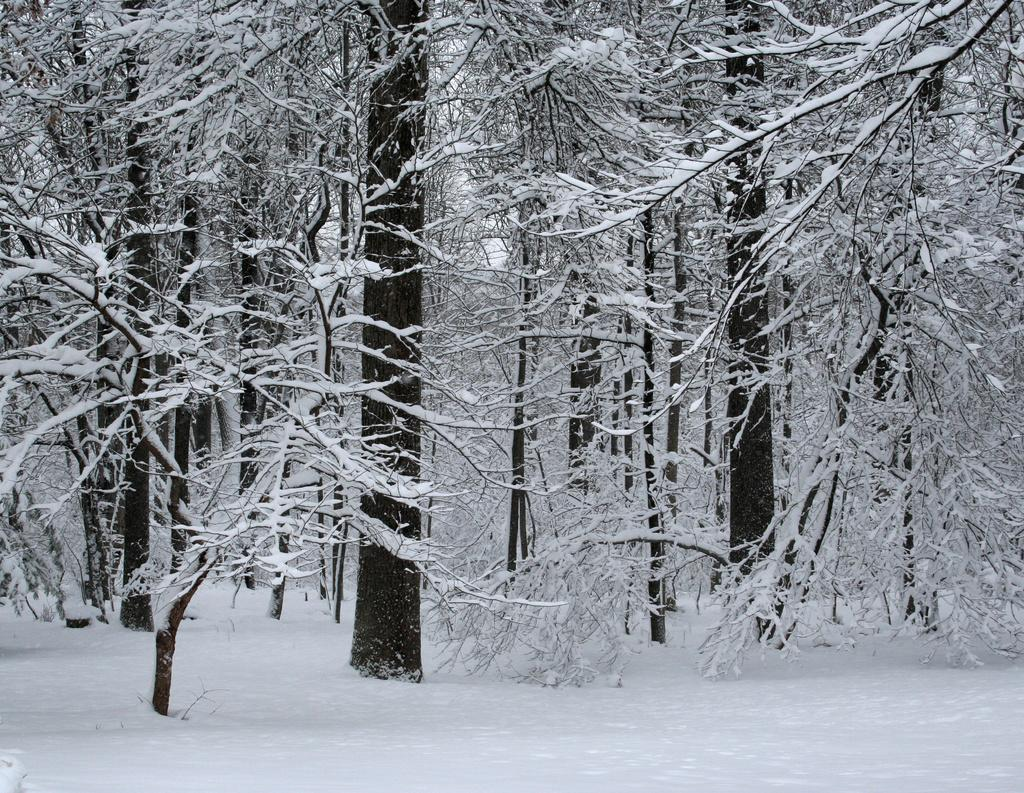What is the color scheme of the image? The image is black and white. What type of natural elements can be seen in the image? There are trees in the image. What is the condition of the trees in the image? The trees are covered with snow. What is visible at the bottom of the image? Snow is visible at the bottom of the image. What arithmetic problem is being solved on the tree in the image? There is no arithmetic problem present in the image; it features trees covered with snow. How long is the recess period for the children playing in the snow in the image? There are no children playing in the snow in the image; it only shows trees covered with snow. 